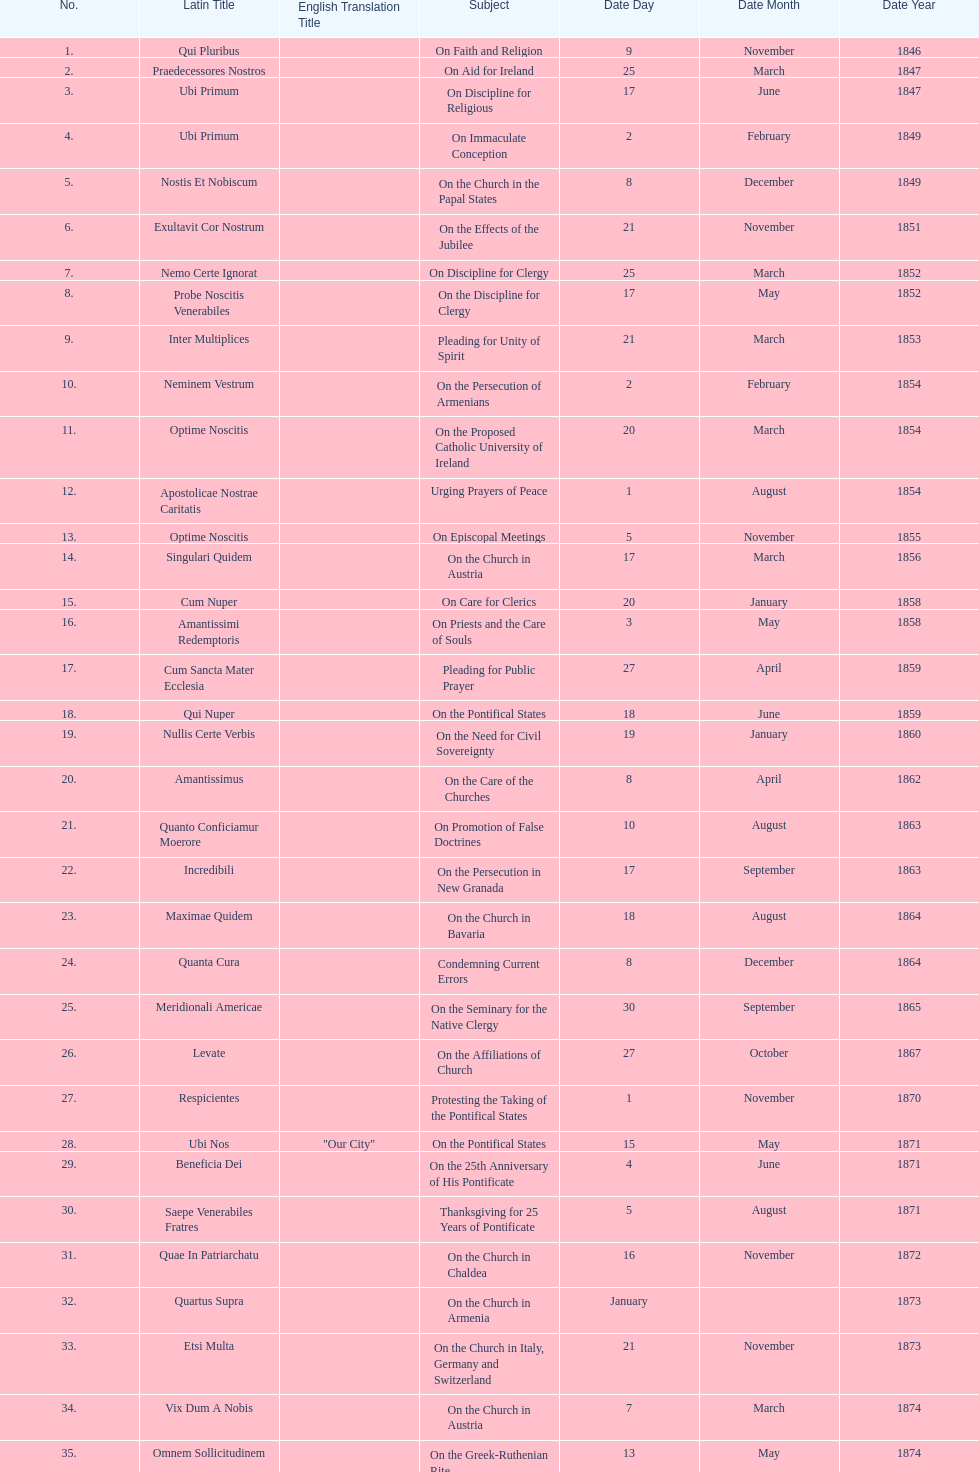Could you parse the entire table? {'header': ['No.', 'Latin Title', 'English Translation Title', 'Subject', 'Date Day', 'Date Month', 'Date Year'], 'rows': [['1.', 'Qui Pluribus', '', 'On Faith and Religion', '9', 'November', '1846'], ['2.', 'Praedecessores Nostros', '', 'On Aid for Ireland', '25', 'March', '1847'], ['3.', 'Ubi Primum', '', 'On Discipline for Religious', '17', 'June', '1847'], ['4.', 'Ubi Primum', '', 'On Immaculate Conception', '2', 'February', '1849'], ['5.', 'Nostis Et Nobiscum', '', 'On the Church in the Papal States', '8', 'December', '1849'], ['6.', 'Exultavit Cor Nostrum', '', 'On the Effects of the Jubilee', '21', 'November', '1851'], ['7.', 'Nemo Certe Ignorat', '', 'On Discipline for Clergy', '25', 'March', '1852'], ['8.', 'Probe Noscitis Venerabiles', '', 'On the Discipline for Clergy', '17', 'May', '1852'], ['9.', 'Inter Multiplices', '', 'Pleading for Unity of Spirit', '21', 'March', '1853'], ['10.', 'Neminem Vestrum', '', 'On the Persecution of Armenians', '2', 'February', '1854'], ['11.', 'Optime Noscitis', '', 'On the Proposed Catholic University of Ireland', '20', 'March', '1854'], ['12.', 'Apostolicae Nostrae Caritatis', '', 'Urging Prayers of Peace', '1', 'August', '1854'], ['13.', 'Optime Noscitis', '', 'On Episcopal Meetings', '5', 'November', '1855'], ['14.', 'Singulari Quidem', '', 'On the Church in Austria', '17', 'March', '1856'], ['15.', 'Cum Nuper', '', 'On Care for Clerics', '20', 'January', '1858'], ['16.', 'Amantissimi Redemptoris', '', 'On Priests and the Care of Souls', '3', 'May', '1858'], ['17.', 'Cum Sancta Mater Ecclesia', '', 'Pleading for Public Prayer', '27', 'April', '1859'], ['18.', 'Qui Nuper', '', 'On the Pontifical States', '18', 'June', '1859'], ['19.', 'Nullis Certe Verbis', '', 'On the Need for Civil Sovereignty', '19', 'January', '1860'], ['20.', 'Amantissimus', '', 'On the Care of the Churches', '8', 'April', '1862'], ['21.', 'Quanto Conficiamur Moerore', '', 'On Promotion of False Doctrines', '10', 'August', '1863'], ['22.', 'Incredibili', '', 'On the Persecution in New Granada', '17', 'September', '1863'], ['23.', 'Maximae Quidem', '', 'On the Church in Bavaria', '18', 'August', '1864'], ['24.', 'Quanta Cura', '', 'Condemning Current Errors', '8', 'December', '1864'], ['25.', 'Meridionali Americae', '', 'On the Seminary for the Native Clergy', '30', 'September', '1865'], ['26.', 'Levate', '', 'On the Affiliations of Church', '27', 'October', '1867'], ['27.', 'Respicientes', '', 'Protesting the Taking of the Pontifical States', '1', 'November', '1870'], ['28.', 'Ubi Nos', '"Our City"', 'On the Pontifical States', '15', 'May', '1871'], ['29.', 'Beneficia Dei', '', 'On the 25th Anniversary of His Pontificate', '4', 'June', '1871'], ['30.', 'Saepe Venerabiles Fratres', '', 'Thanksgiving for 25 Years of Pontificate', '5', 'August', '1871'], ['31.', 'Quae In Patriarchatu', '', 'On the Church in Chaldea', '16', 'November', '1872'], ['32.', 'Quartus Supra', '', 'On the Church in Armenia', 'January', '', '1873'], ['33.', 'Etsi Multa', '', 'On the Church in Italy, Germany and Switzerland', '21', 'November', '1873'], ['34.', 'Vix Dum A Nobis', '', 'On the Church in Austria', '7', 'March', '1874'], ['35.', 'Omnem Sollicitudinem', '', 'On the Greek-Ruthenian Rite', '13', 'May', '1874'], ['36.', 'Gravibus Ecclesiae', '', 'Proclaiming A Jubilee', '24', 'December', '1874'], ['37.', 'Quod Nunquam', '', 'On the Church in Prussia', '5', 'February', '1875'], ['38.', 'Graves Ac Diuturnae', '', 'On the Church in Switzerland', '23', 'March', '1875']]} What is the previous subject after on the effects of the jubilee? On the Church in the Papal States. 